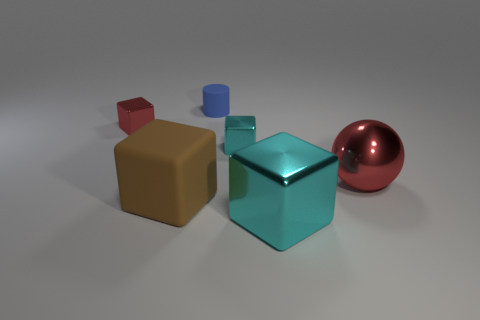There is a cyan object that is the same size as the matte cube; what is its shape?
Your answer should be compact. Cube. Are there any other tiny red shiny objects of the same shape as the small red shiny thing?
Ensure brevity in your answer.  No. Is the large cyan cube made of the same material as the big thing behind the large rubber block?
Ensure brevity in your answer.  Yes. The red object on the right side of the big metal thing that is in front of the red metal sphere is made of what material?
Ensure brevity in your answer.  Metal. Are there more blue things that are right of the big red sphere than large brown blocks?
Your response must be concise. No. Are any tiny gray shiny spheres visible?
Provide a succinct answer. No. There is a large shiny sphere behind the big brown rubber thing; what color is it?
Your answer should be compact. Red. What is the material of the red thing that is the same size as the blue thing?
Make the answer very short. Metal. What number of other objects are there of the same material as the large red object?
Make the answer very short. 3. There is a block that is both to the right of the red metallic cube and left of the tiny cyan cube; what is its color?
Give a very brief answer. Brown. 